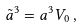Convert formula to latex. <formula><loc_0><loc_0><loc_500><loc_500>\tilde { a } ^ { 3 } = a ^ { 3 } V _ { 0 } \, ,</formula> 